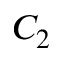Convert formula to latex. <formula><loc_0><loc_0><loc_500><loc_500>C _ { 2 }</formula> 